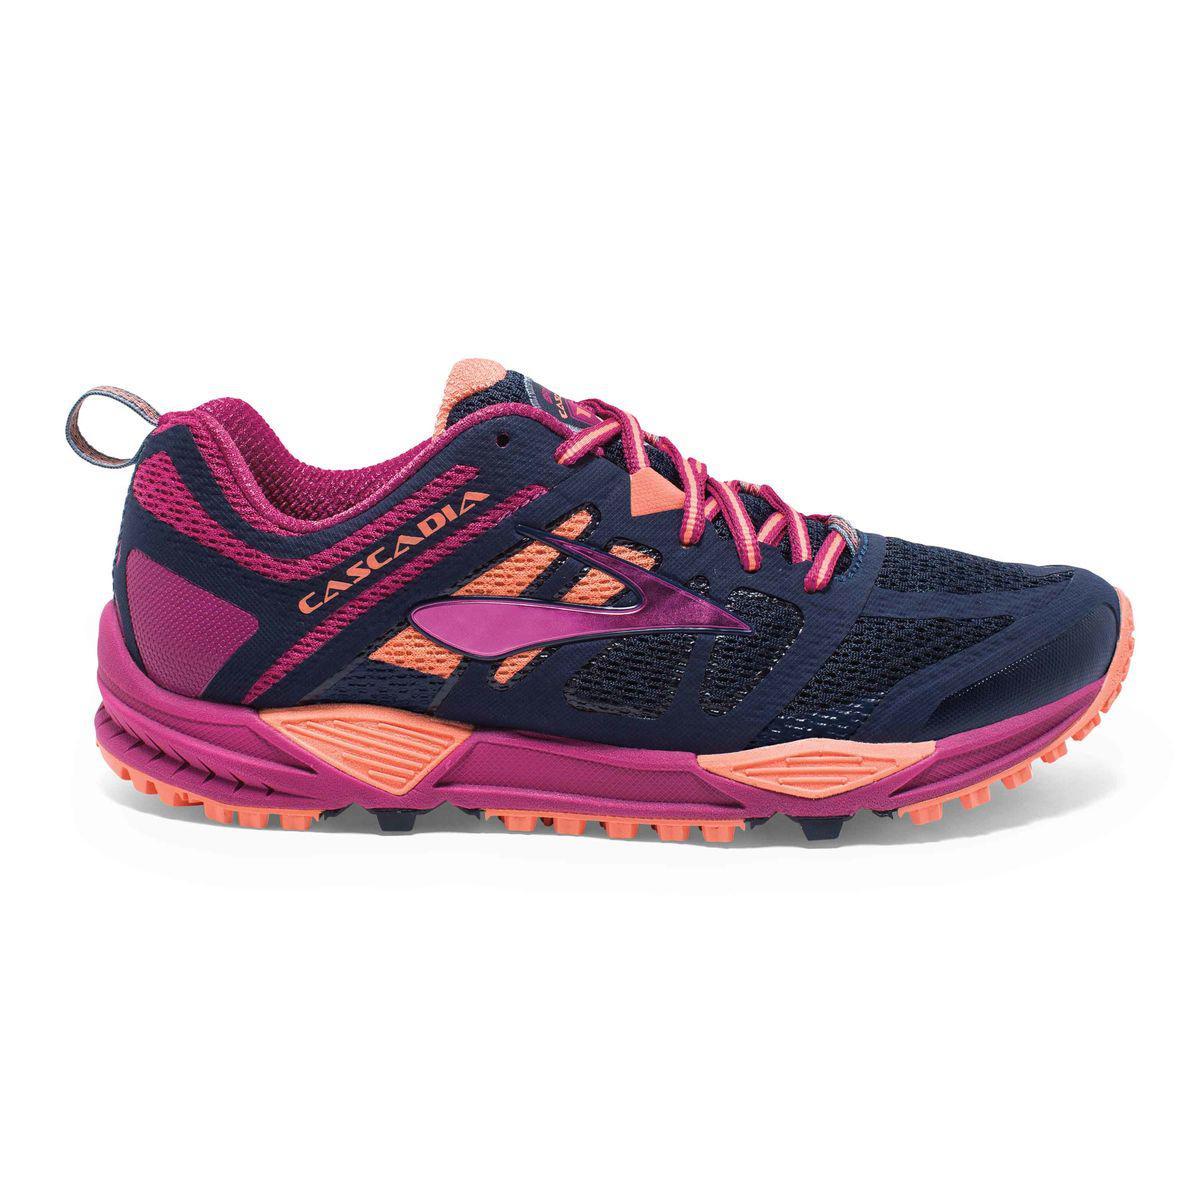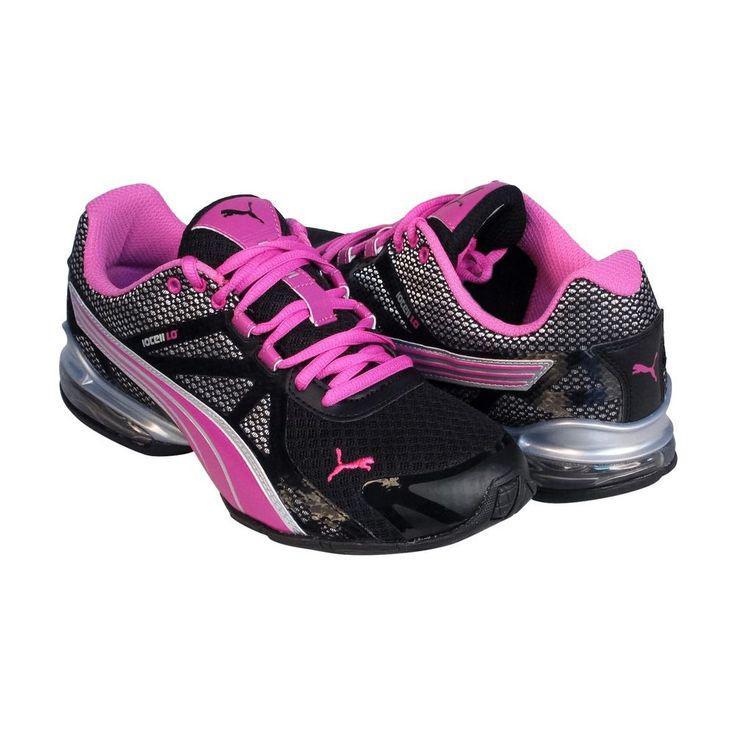The first image is the image on the left, the second image is the image on the right. For the images displayed, is the sentence "At least one shoe in the image on the right has pink laces." factually correct? Answer yes or no. Yes. 